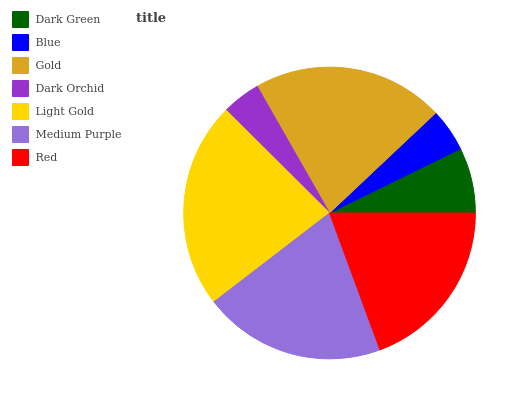Is Dark Orchid the minimum?
Answer yes or no. Yes. Is Light Gold the maximum?
Answer yes or no. Yes. Is Blue the minimum?
Answer yes or no. No. Is Blue the maximum?
Answer yes or no. No. Is Dark Green greater than Blue?
Answer yes or no. Yes. Is Blue less than Dark Green?
Answer yes or no. Yes. Is Blue greater than Dark Green?
Answer yes or no. No. Is Dark Green less than Blue?
Answer yes or no. No. Is Red the high median?
Answer yes or no. Yes. Is Red the low median?
Answer yes or no. Yes. Is Light Gold the high median?
Answer yes or no. No. Is Medium Purple the low median?
Answer yes or no. No. 